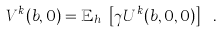Convert formula to latex. <formula><loc_0><loc_0><loc_500><loc_500>V ^ { k } ( b , 0 ) = \mathbb { E } _ { h _ { k } } \left [ \gamma U ^ { k } ( b , 0 , 0 ) \right ] \ .</formula> 